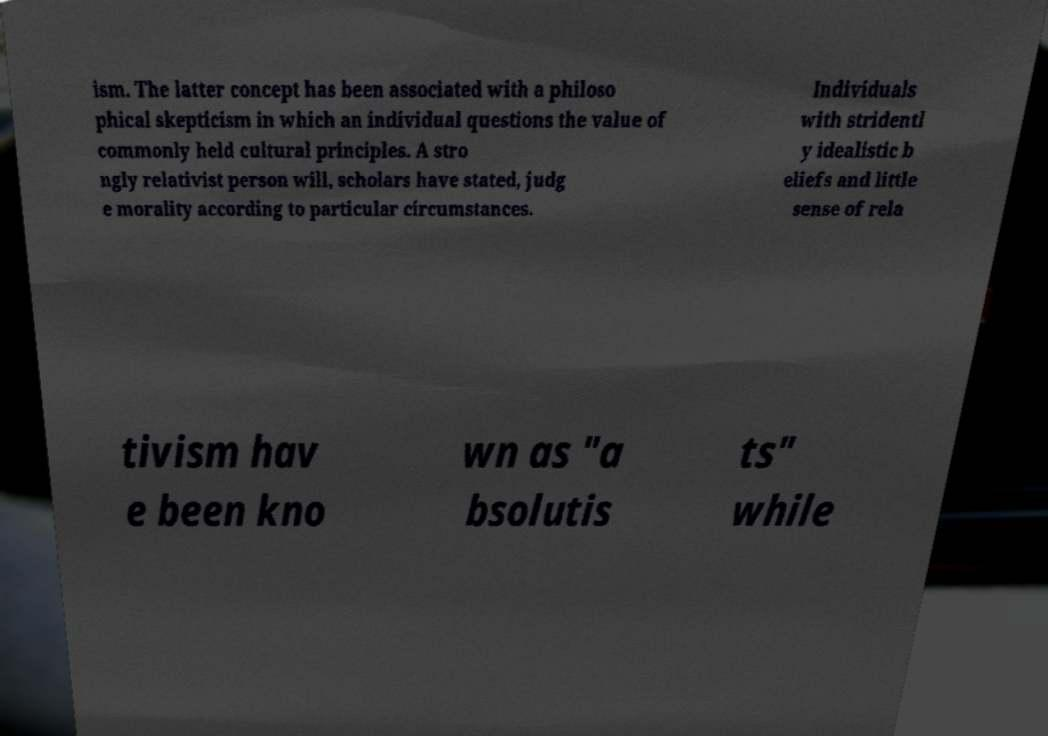Please identify and transcribe the text found in this image. ism. The latter concept has been associated with a philoso phical skepticism in which an individual questions the value of commonly held cultural principles. A stro ngly relativist person will, scholars have stated, judg e morality according to particular circumstances. Individuals with stridentl y idealistic b eliefs and little sense of rela tivism hav e been kno wn as "a bsolutis ts" while 